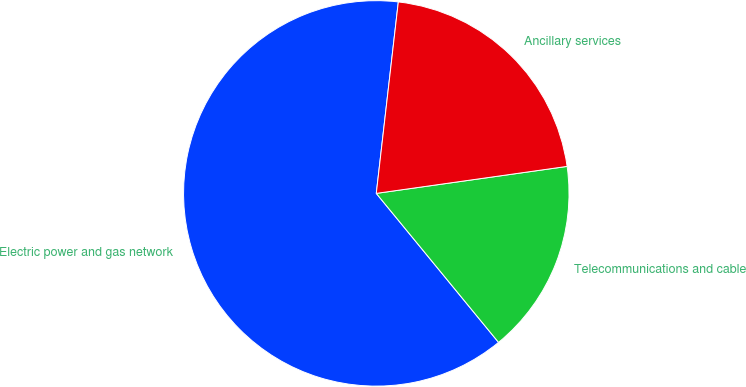<chart> <loc_0><loc_0><loc_500><loc_500><pie_chart><fcel>Electric power and gas network<fcel>Telecommunications and cable<fcel>Ancillary services<nl><fcel>62.76%<fcel>16.3%<fcel>20.94%<nl></chart> 